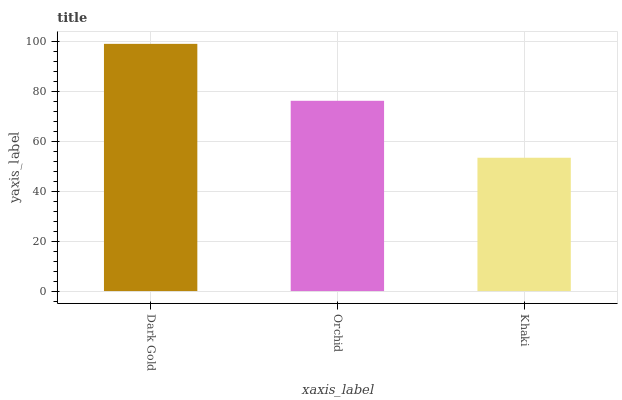Is Orchid the minimum?
Answer yes or no. No. Is Orchid the maximum?
Answer yes or no. No. Is Dark Gold greater than Orchid?
Answer yes or no. Yes. Is Orchid less than Dark Gold?
Answer yes or no. Yes. Is Orchid greater than Dark Gold?
Answer yes or no. No. Is Dark Gold less than Orchid?
Answer yes or no. No. Is Orchid the high median?
Answer yes or no. Yes. Is Orchid the low median?
Answer yes or no. Yes. Is Khaki the high median?
Answer yes or no. No. Is Khaki the low median?
Answer yes or no. No. 